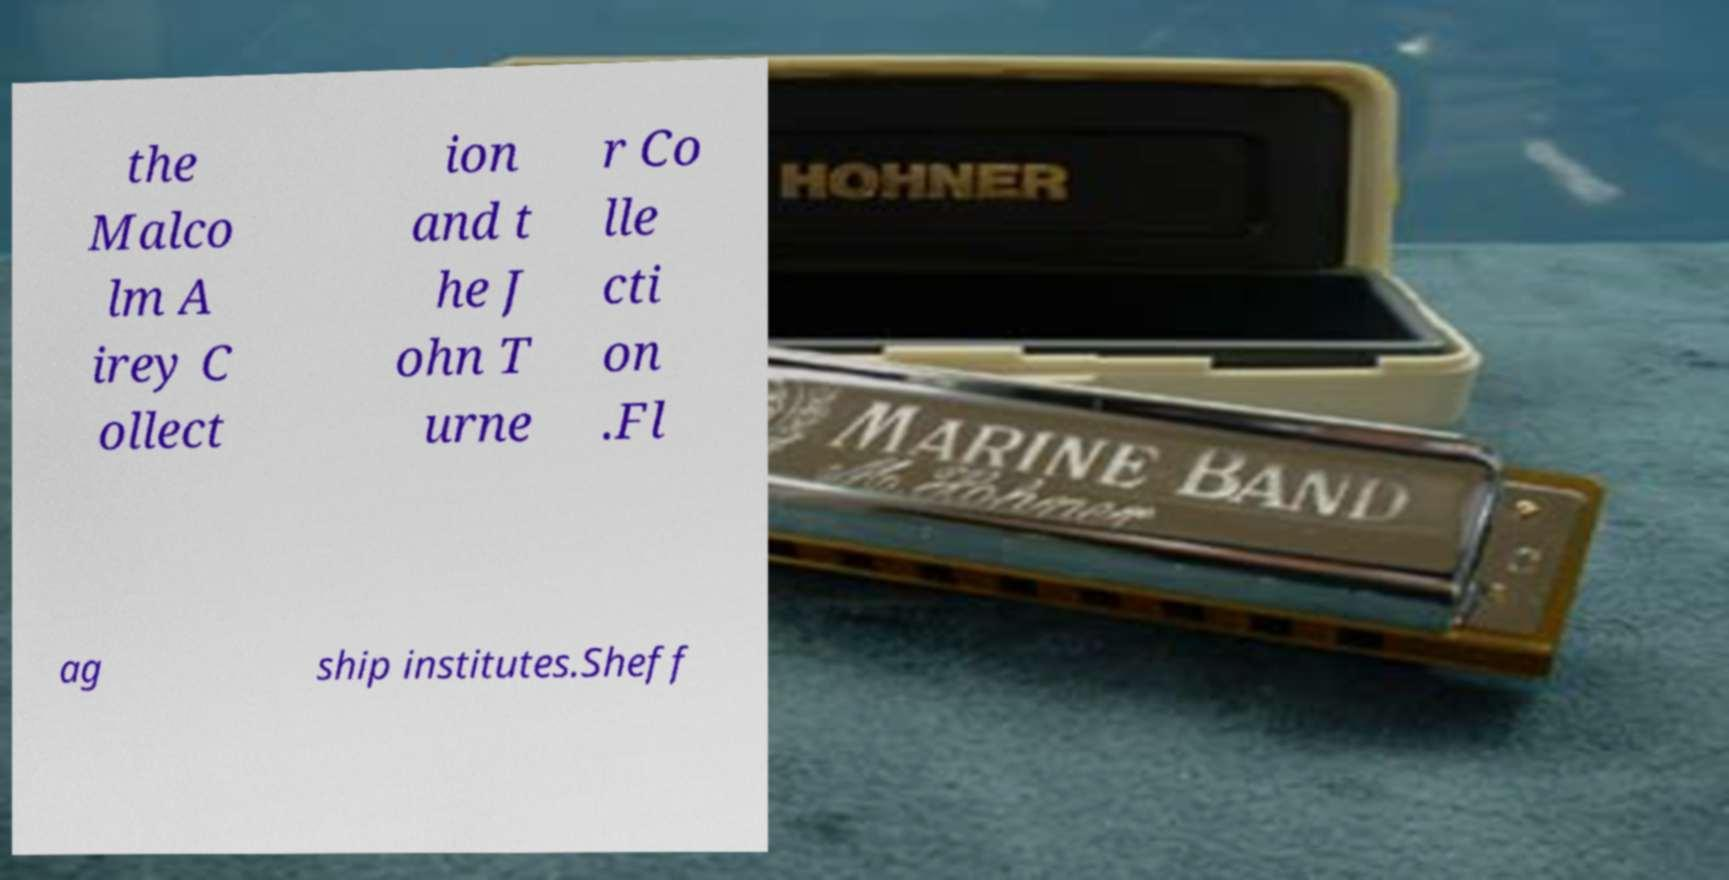What messages or text are displayed in this image? I need them in a readable, typed format. the Malco lm A irey C ollect ion and t he J ohn T urne r Co lle cti on .Fl ag ship institutes.Sheff 